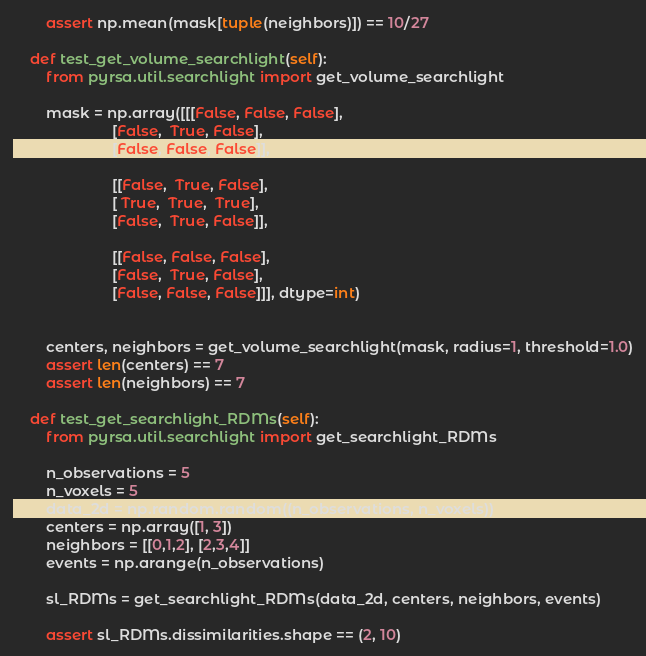<code> <loc_0><loc_0><loc_500><loc_500><_Python_>        assert np.mean(mask[tuple(neighbors)]) == 10/27

    def test_get_volume_searchlight(self):
        from pyrsa.util.searchlight import get_volume_searchlight

        mask = np.array([[[False, False, False],
                        [False,  True, False],
                        [False, False, False]],

                        [[False,  True, False],
                        [ True,  True,  True],
                        [False,  True, False]],

                        [[False, False, False],
                        [False,  True, False],
                        [False, False, False]]], dtype=int)


        centers, neighbors = get_volume_searchlight(mask, radius=1, threshold=1.0)
        assert len(centers) == 7
        assert len(neighbors) == 7

    def test_get_searchlight_RDMs(self):
        from pyrsa.util.searchlight import get_searchlight_RDMs

        n_observations = 5
        n_voxels = 5
        data_2d = np.random.random((n_observations, n_voxels))
        centers = np.array([1, 3])
        neighbors = [[0,1,2], [2,3,4]]
        events = np.arange(n_observations)

        sl_RDMs = get_searchlight_RDMs(data_2d, centers, neighbors, events)

        assert sl_RDMs.dissimilarities.shape == (2, 10)
</code> 